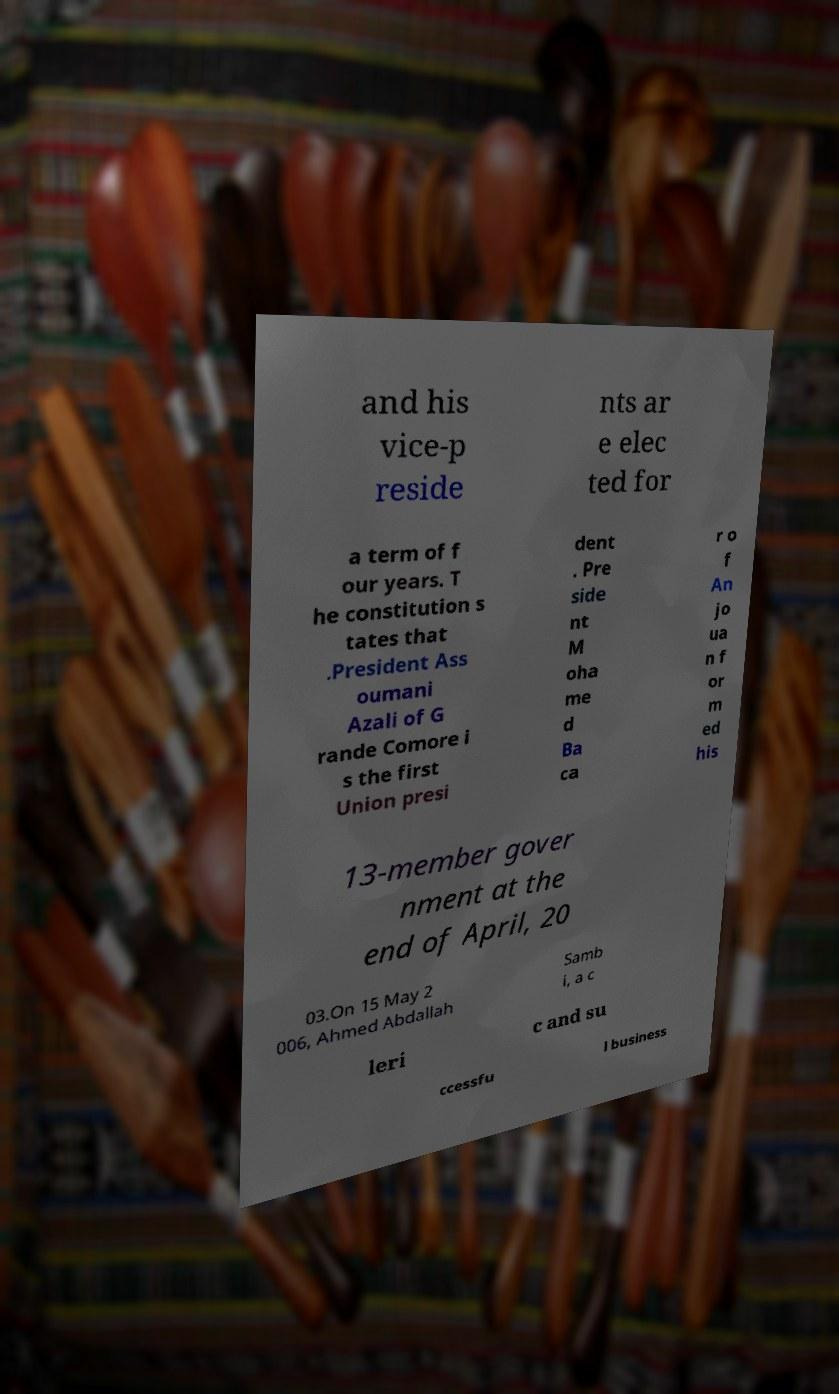Could you extract and type out the text from this image? and his vice-p reside nts ar e elec ted for a term of f our years. T he constitution s tates that .President Ass oumani Azali of G rande Comore i s the first Union presi dent . Pre side nt M oha me d Ba ca r o f An jo ua n f or m ed his 13-member gover nment at the end of April, 20 03.On 15 May 2 006, Ahmed Abdallah Samb i, a c leri c and su ccessfu l business 